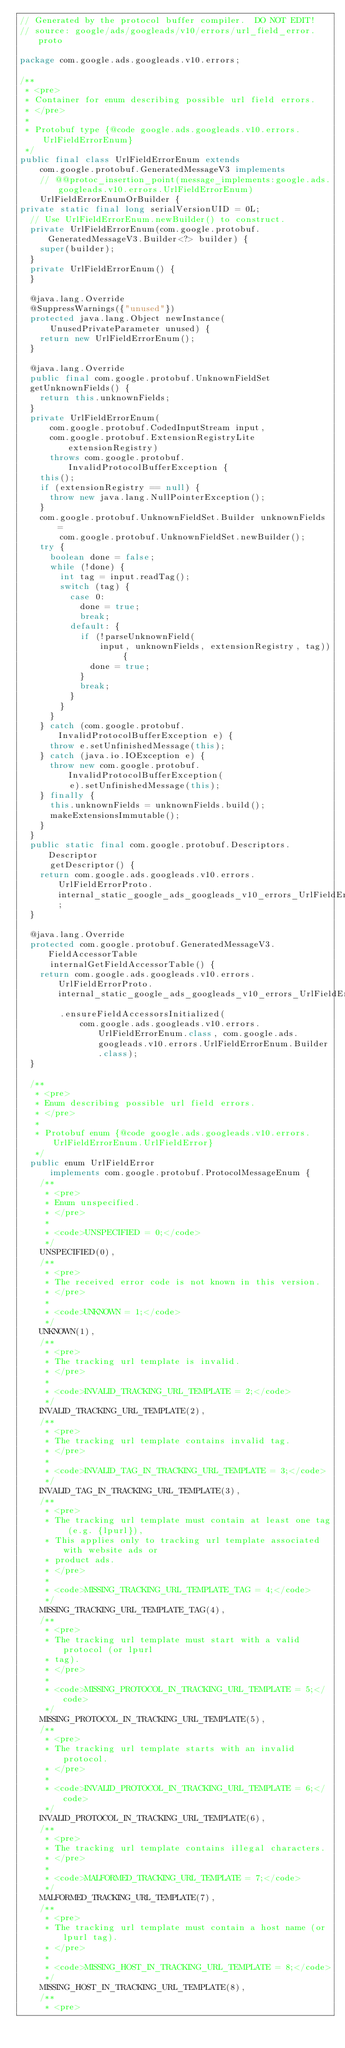Convert code to text. <code><loc_0><loc_0><loc_500><loc_500><_Java_>// Generated by the protocol buffer compiler.  DO NOT EDIT!
// source: google/ads/googleads/v10/errors/url_field_error.proto

package com.google.ads.googleads.v10.errors;

/**
 * <pre>
 * Container for enum describing possible url field errors.
 * </pre>
 *
 * Protobuf type {@code google.ads.googleads.v10.errors.UrlFieldErrorEnum}
 */
public final class UrlFieldErrorEnum extends
    com.google.protobuf.GeneratedMessageV3 implements
    // @@protoc_insertion_point(message_implements:google.ads.googleads.v10.errors.UrlFieldErrorEnum)
    UrlFieldErrorEnumOrBuilder {
private static final long serialVersionUID = 0L;
  // Use UrlFieldErrorEnum.newBuilder() to construct.
  private UrlFieldErrorEnum(com.google.protobuf.GeneratedMessageV3.Builder<?> builder) {
    super(builder);
  }
  private UrlFieldErrorEnum() {
  }

  @java.lang.Override
  @SuppressWarnings({"unused"})
  protected java.lang.Object newInstance(
      UnusedPrivateParameter unused) {
    return new UrlFieldErrorEnum();
  }

  @java.lang.Override
  public final com.google.protobuf.UnknownFieldSet
  getUnknownFields() {
    return this.unknownFields;
  }
  private UrlFieldErrorEnum(
      com.google.protobuf.CodedInputStream input,
      com.google.protobuf.ExtensionRegistryLite extensionRegistry)
      throws com.google.protobuf.InvalidProtocolBufferException {
    this();
    if (extensionRegistry == null) {
      throw new java.lang.NullPointerException();
    }
    com.google.protobuf.UnknownFieldSet.Builder unknownFields =
        com.google.protobuf.UnknownFieldSet.newBuilder();
    try {
      boolean done = false;
      while (!done) {
        int tag = input.readTag();
        switch (tag) {
          case 0:
            done = true;
            break;
          default: {
            if (!parseUnknownField(
                input, unknownFields, extensionRegistry, tag)) {
              done = true;
            }
            break;
          }
        }
      }
    } catch (com.google.protobuf.InvalidProtocolBufferException e) {
      throw e.setUnfinishedMessage(this);
    } catch (java.io.IOException e) {
      throw new com.google.protobuf.InvalidProtocolBufferException(
          e).setUnfinishedMessage(this);
    } finally {
      this.unknownFields = unknownFields.build();
      makeExtensionsImmutable();
    }
  }
  public static final com.google.protobuf.Descriptors.Descriptor
      getDescriptor() {
    return com.google.ads.googleads.v10.errors.UrlFieldErrorProto.internal_static_google_ads_googleads_v10_errors_UrlFieldErrorEnum_descriptor;
  }

  @java.lang.Override
  protected com.google.protobuf.GeneratedMessageV3.FieldAccessorTable
      internalGetFieldAccessorTable() {
    return com.google.ads.googleads.v10.errors.UrlFieldErrorProto.internal_static_google_ads_googleads_v10_errors_UrlFieldErrorEnum_fieldAccessorTable
        .ensureFieldAccessorsInitialized(
            com.google.ads.googleads.v10.errors.UrlFieldErrorEnum.class, com.google.ads.googleads.v10.errors.UrlFieldErrorEnum.Builder.class);
  }

  /**
   * <pre>
   * Enum describing possible url field errors.
   * </pre>
   *
   * Protobuf enum {@code google.ads.googleads.v10.errors.UrlFieldErrorEnum.UrlFieldError}
   */
  public enum UrlFieldError
      implements com.google.protobuf.ProtocolMessageEnum {
    /**
     * <pre>
     * Enum unspecified.
     * </pre>
     *
     * <code>UNSPECIFIED = 0;</code>
     */
    UNSPECIFIED(0),
    /**
     * <pre>
     * The received error code is not known in this version.
     * </pre>
     *
     * <code>UNKNOWN = 1;</code>
     */
    UNKNOWN(1),
    /**
     * <pre>
     * The tracking url template is invalid.
     * </pre>
     *
     * <code>INVALID_TRACKING_URL_TEMPLATE = 2;</code>
     */
    INVALID_TRACKING_URL_TEMPLATE(2),
    /**
     * <pre>
     * The tracking url template contains invalid tag.
     * </pre>
     *
     * <code>INVALID_TAG_IN_TRACKING_URL_TEMPLATE = 3;</code>
     */
    INVALID_TAG_IN_TRACKING_URL_TEMPLATE(3),
    /**
     * <pre>
     * The tracking url template must contain at least one tag (e.g. {lpurl}),
     * This applies only to tracking url template associated with website ads or
     * product ads.
     * </pre>
     *
     * <code>MISSING_TRACKING_URL_TEMPLATE_TAG = 4;</code>
     */
    MISSING_TRACKING_URL_TEMPLATE_TAG(4),
    /**
     * <pre>
     * The tracking url template must start with a valid protocol (or lpurl
     * tag).
     * </pre>
     *
     * <code>MISSING_PROTOCOL_IN_TRACKING_URL_TEMPLATE = 5;</code>
     */
    MISSING_PROTOCOL_IN_TRACKING_URL_TEMPLATE(5),
    /**
     * <pre>
     * The tracking url template starts with an invalid protocol.
     * </pre>
     *
     * <code>INVALID_PROTOCOL_IN_TRACKING_URL_TEMPLATE = 6;</code>
     */
    INVALID_PROTOCOL_IN_TRACKING_URL_TEMPLATE(6),
    /**
     * <pre>
     * The tracking url template contains illegal characters.
     * </pre>
     *
     * <code>MALFORMED_TRACKING_URL_TEMPLATE = 7;</code>
     */
    MALFORMED_TRACKING_URL_TEMPLATE(7),
    /**
     * <pre>
     * The tracking url template must contain a host name (or lpurl tag).
     * </pre>
     *
     * <code>MISSING_HOST_IN_TRACKING_URL_TEMPLATE = 8;</code>
     */
    MISSING_HOST_IN_TRACKING_URL_TEMPLATE(8),
    /**
     * <pre></code> 